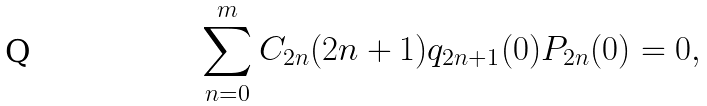Convert formula to latex. <formula><loc_0><loc_0><loc_500><loc_500>\sum _ { n = 0 } ^ { m } C _ { 2 n } ( 2 n + 1 ) q _ { 2 n + 1 } ( 0 ) P _ { 2 n } ( 0 ) = 0 ,</formula> 